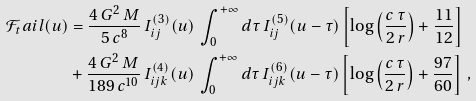Convert formula to latex. <formula><loc_0><loc_0><loc_500><loc_500>\mathcal { F } _ { t } a i l ( u ) & = \frac { 4 \, G ^ { 2 } \, M } { 5 \, c ^ { 8 } } \, I _ { i j } ^ { ( 3 ) } ( u ) \, \int _ { 0 } ^ { + \infty } d \tau \, I ^ { ( 5 ) } _ { i j } ( u - \tau ) \left [ \log \left ( \frac { c \, \tau } { 2 \, r } \right ) + \frac { 1 1 } { 1 2 } \right ] \\ & + \frac { 4 \, G ^ { 2 } \, M } { 1 8 9 \, c ^ { 1 0 } } \, I _ { i j k } ^ { ( 4 ) } ( u ) \, \int _ { 0 } ^ { + \infty } d \tau \, I ^ { ( 6 ) } _ { i j k } ( u - \tau ) \left [ \log \left ( \frac { c \, \tau } { 2 \, r } \right ) + \frac { 9 7 } { 6 0 } \right ] \, ,</formula> 